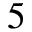<formula> <loc_0><loc_0><loc_500><loc_500>5</formula> 